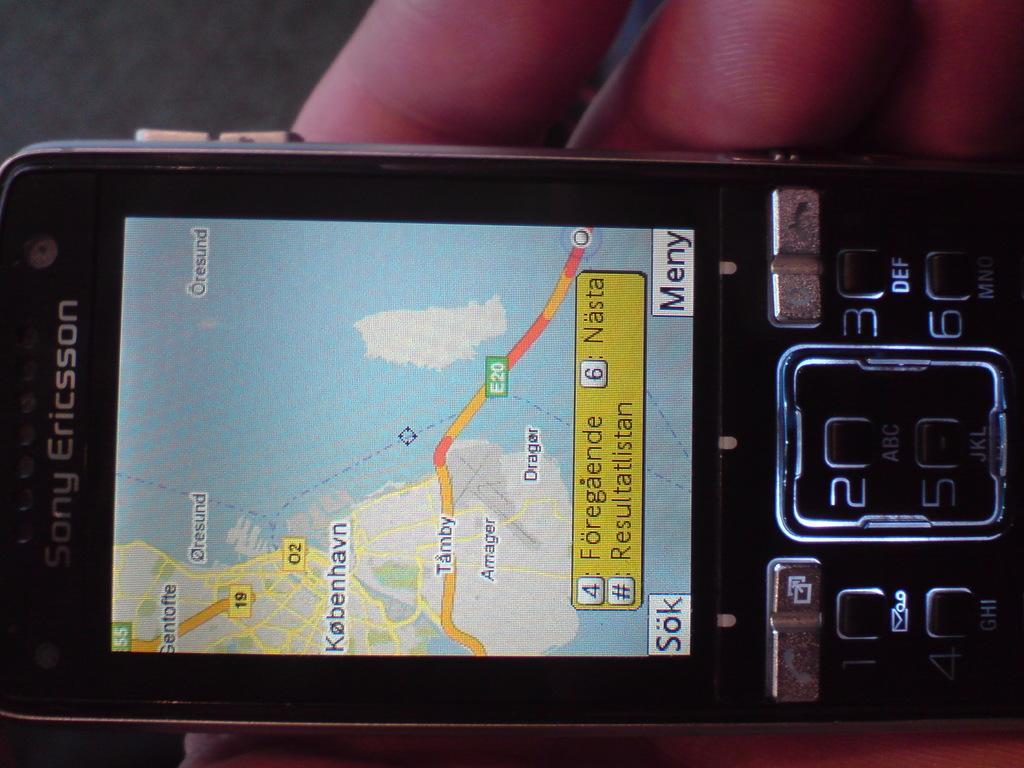<image>
Render a clear and concise summary of the photo. A map is displayed on a Sony Ericsson phone. 